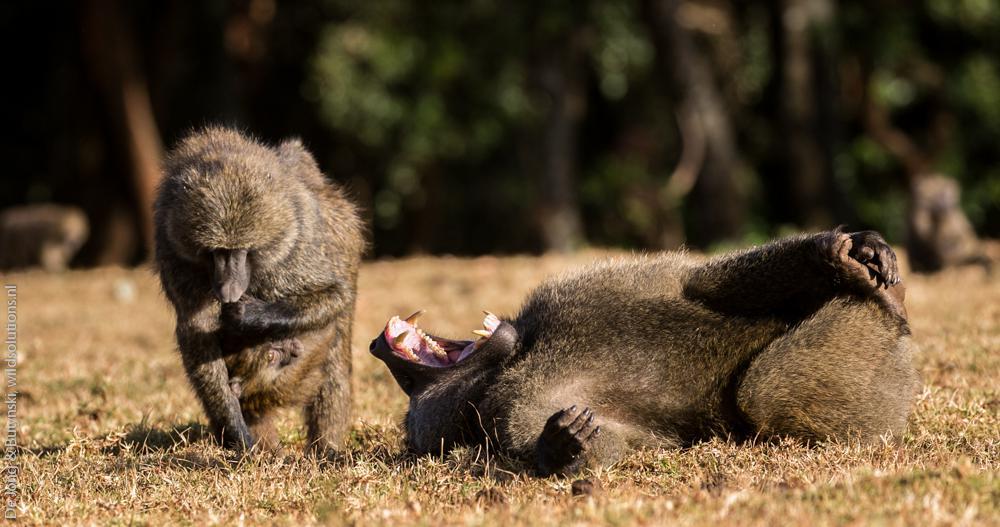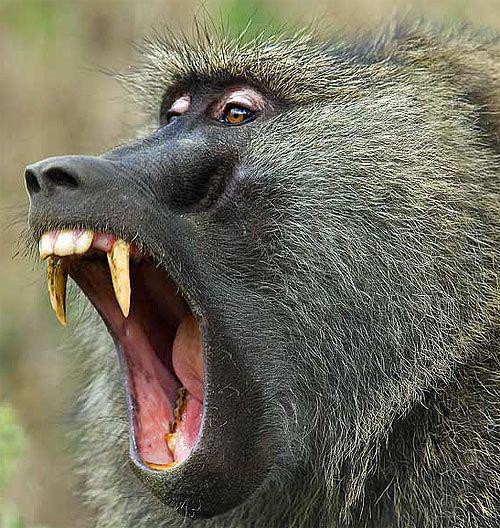The first image is the image on the left, the second image is the image on the right. Analyze the images presented: Is the assertion "Each image contains a single baboon, and no baboon has a wide-open mouth." valid? Answer yes or no. No. The first image is the image on the left, the second image is the image on the right. Examine the images to the left and right. Is the description "There are at least three baboons." accurate? Answer yes or no. Yes. 